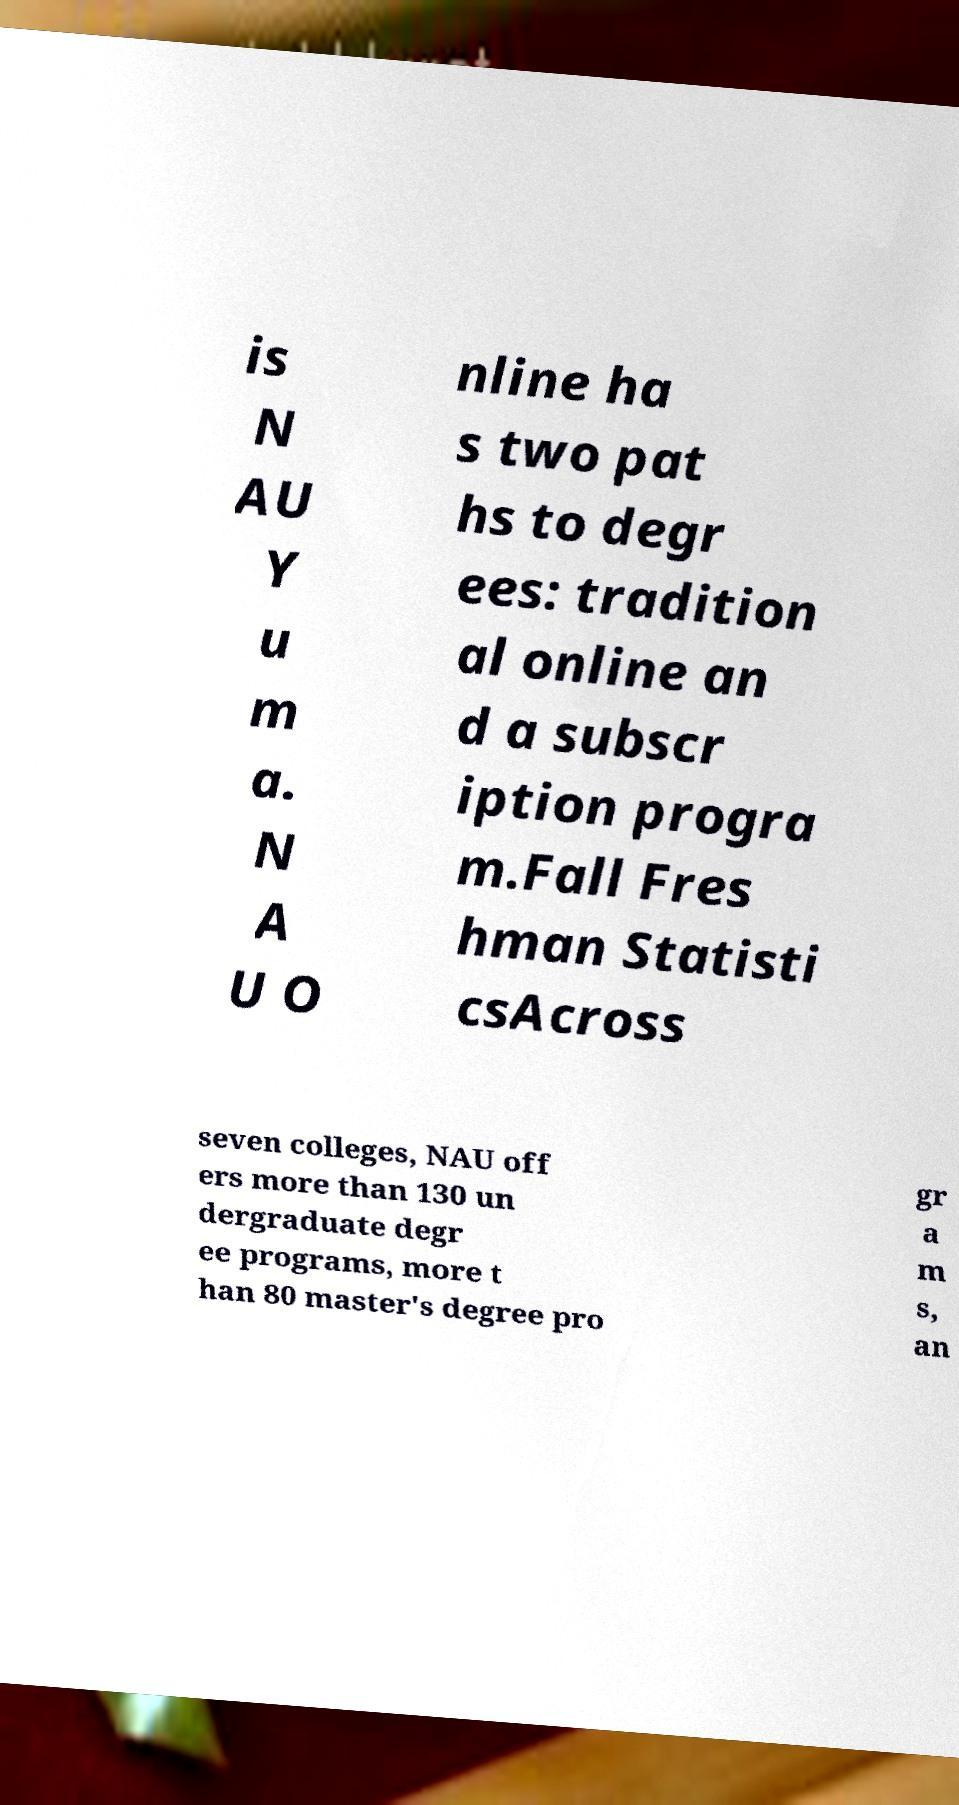What messages or text are displayed in this image? I need them in a readable, typed format. is N AU Y u m a. N A U O nline ha s two pat hs to degr ees: tradition al online an d a subscr iption progra m.Fall Fres hman Statisti csAcross seven colleges, NAU off ers more than 130 un dergraduate degr ee programs, more t han 80 master's degree pro gr a m s, an 